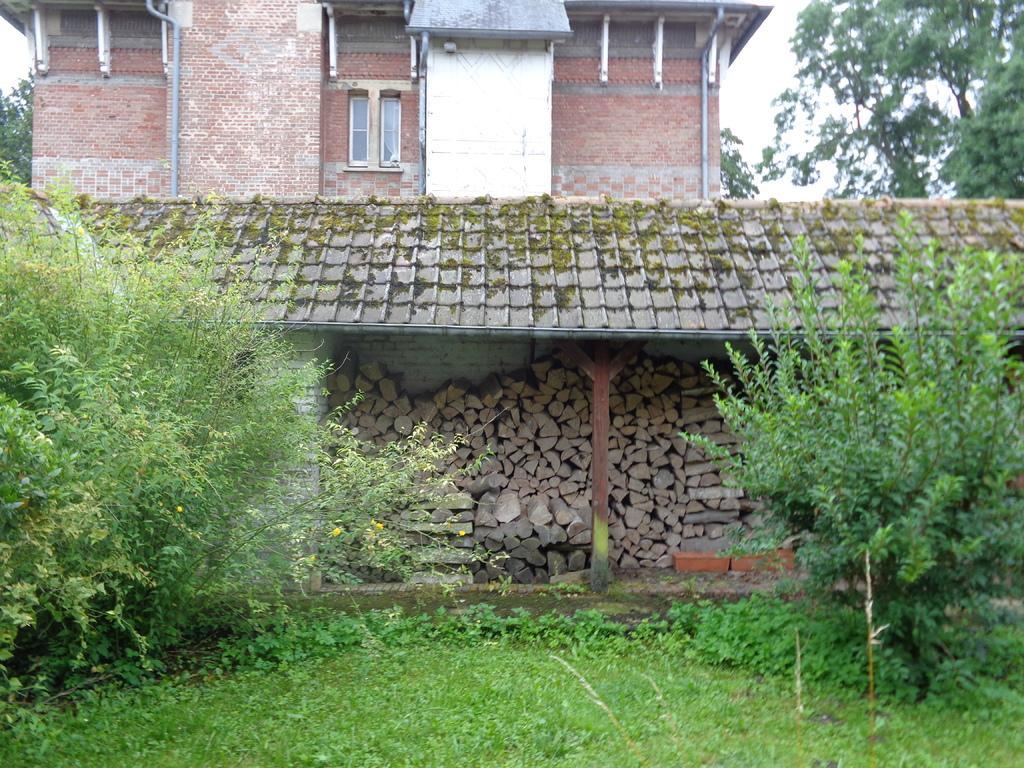Describe this image in one or two sentences. In this picture we can see plants, trees, wooden logs, building with windows, pipes, roof, pillar, walls and in the background we can see the sky. 